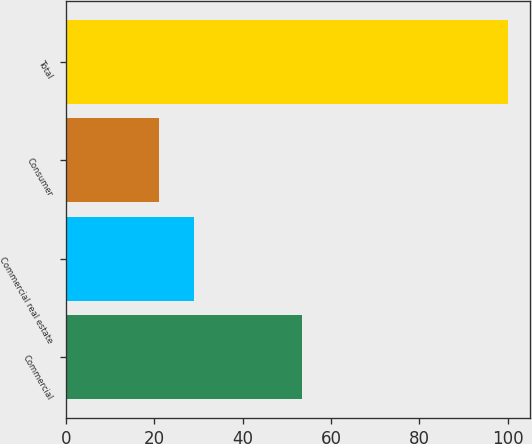Convert chart. <chart><loc_0><loc_0><loc_500><loc_500><bar_chart><fcel>Commercial<fcel>Commercial real estate<fcel>Consumer<fcel>Total<nl><fcel>53.5<fcel>29.08<fcel>21.2<fcel>100<nl></chart> 